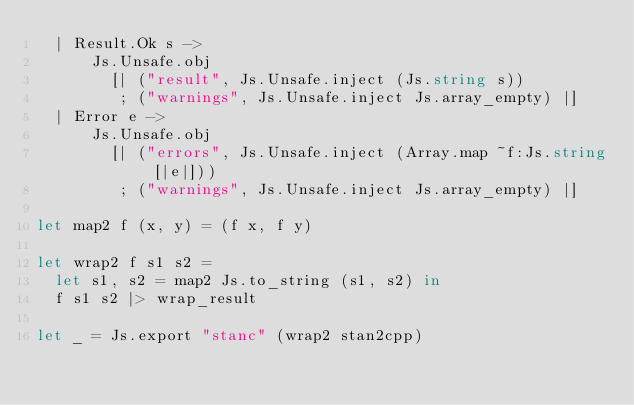Convert code to text. <code><loc_0><loc_0><loc_500><loc_500><_OCaml_>  | Result.Ok s ->
      Js.Unsafe.obj
        [| ("result", Js.Unsafe.inject (Js.string s))
         ; ("warnings", Js.Unsafe.inject Js.array_empty) |]
  | Error e ->
      Js.Unsafe.obj
        [| ("errors", Js.Unsafe.inject (Array.map ~f:Js.string [|e|]))
         ; ("warnings", Js.Unsafe.inject Js.array_empty) |]

let map2 f (x, y) = (f x, f y)

let wrap2 f s1 s2 =
  let s1, s2 = map2 Js.to_string (s1, s2) in
  f s1 s2 |> wrap_result

let _ = Js.export "stanc" (wrap2 stan2cpp)
</code> 